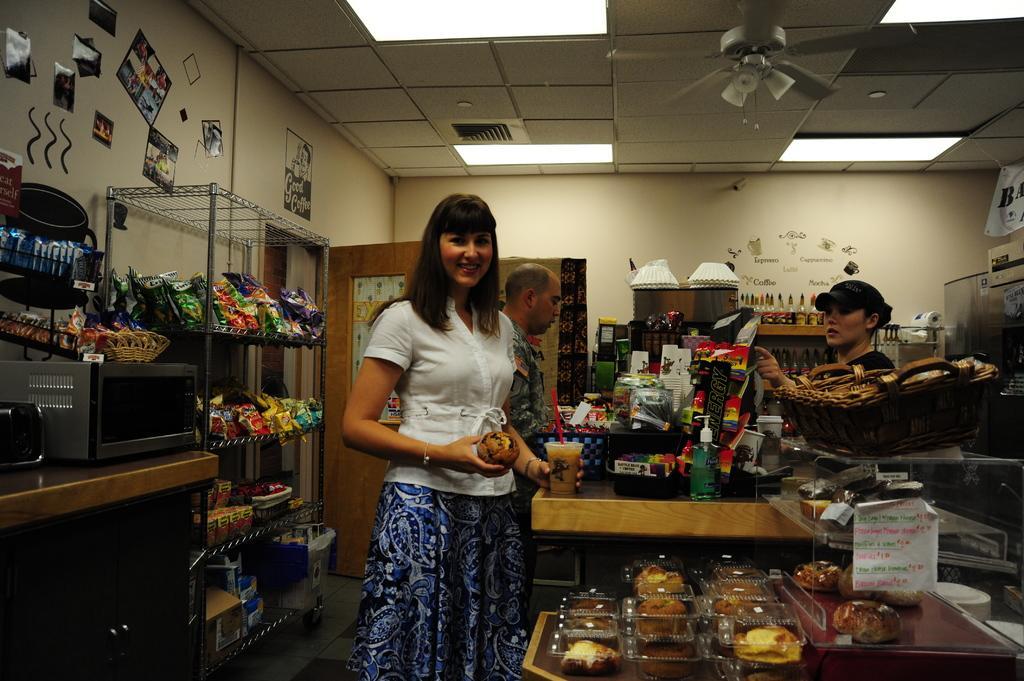Can you describe this image briefly? In the image in the center, we can see few people were standing around the table and they were holding some objects. And the front person is smiling. On the table, we can see plastic boxes, spray bottles, banners, glasses, containers, baskets, some food items and a few other objects. In the background there is a wall, roof, a table, fan, microwave oven, racks, lights, chip packets, boxes, spray bottles, baskets, containers, collection of photos and a few other objects. 